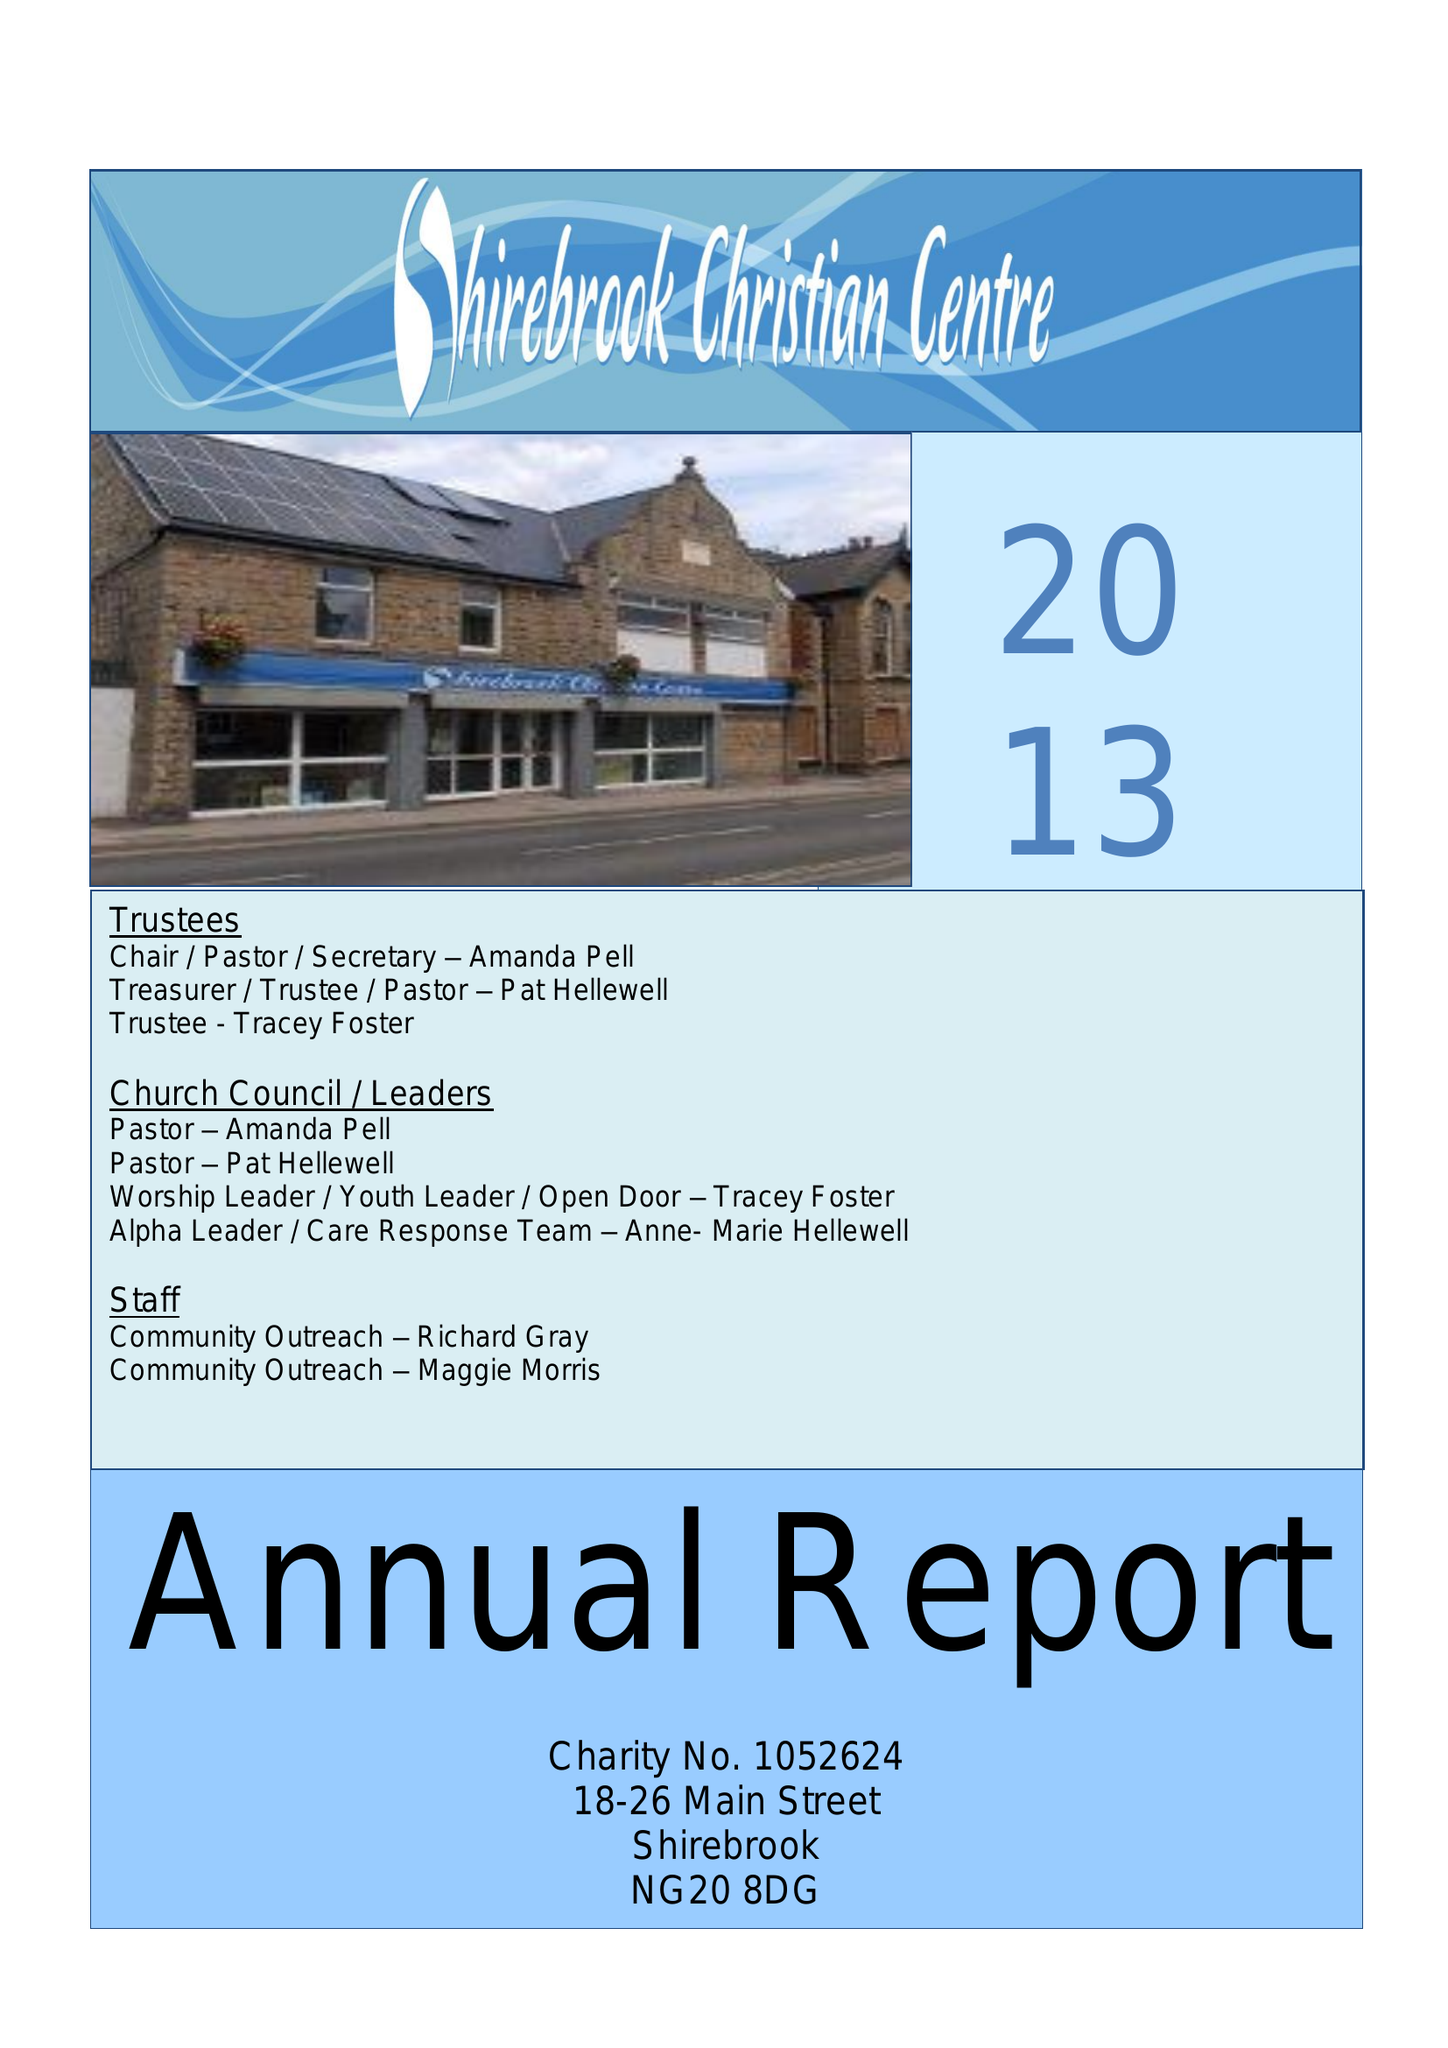What is the value for the address__post_town?
Answer the question using a single word or phrase. MANSFIELD 